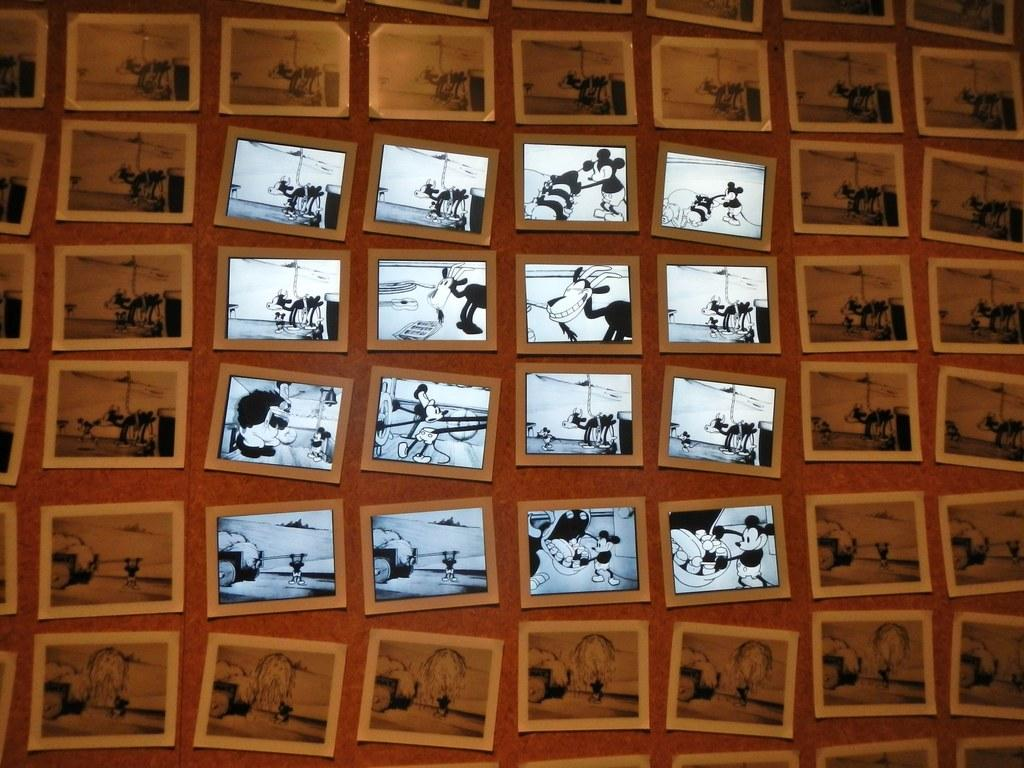What is attached to the wall in the image? There are frames attached to a wall in the image. What type of images are contained within the frames? The frames contain cartoon images. Is there a squirrel being punished in one of the cartoon images? There is no squirrel or any indication of punishment in the cartoon images; they only contain cartoon images as mentioned in the facts. 